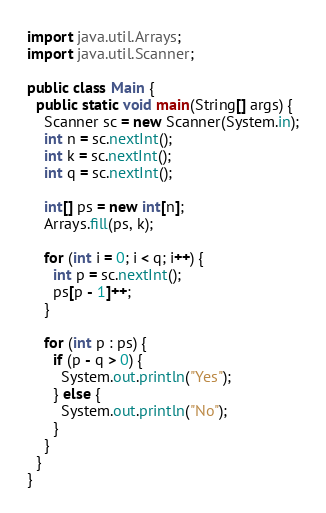Convert code to text. <code><loc_0><loc_0><loc_500><loc_500><_Java_>import java.util.Arrays;
import java.util.Scanner;

public class Main {
  public static void main(String[] args) {
    Scanner sc = new Scanner(System.in);
    int n = sc.nextInt();
    int k = sc.nextInt();
    int q = sc.nextInt();

    int[] ps = new int[n];
    Arrays.fill(ps, k);

    for (int i = 0; i < q; i++) {
      int p = sc.nextInt();
      ps[p - 1]++;
    }

    for (int p : ps) {
      if (p - q > 0) {
        System.out.println("Yes");
      } else {
        System.out.println("No");
      }
    }
  }
}</code> 